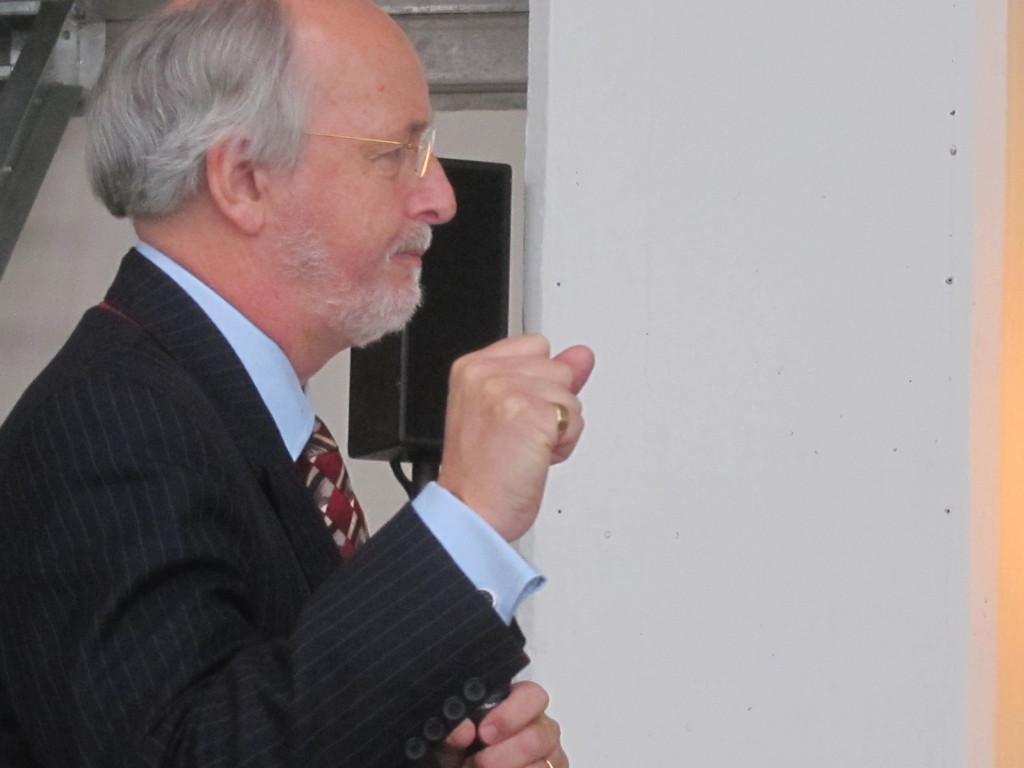Describe this image in one or two sentences. In this image, at the left side there is an old man standing and he is wearing specs, in the background there is a white color wall and there is a black color speaker. 